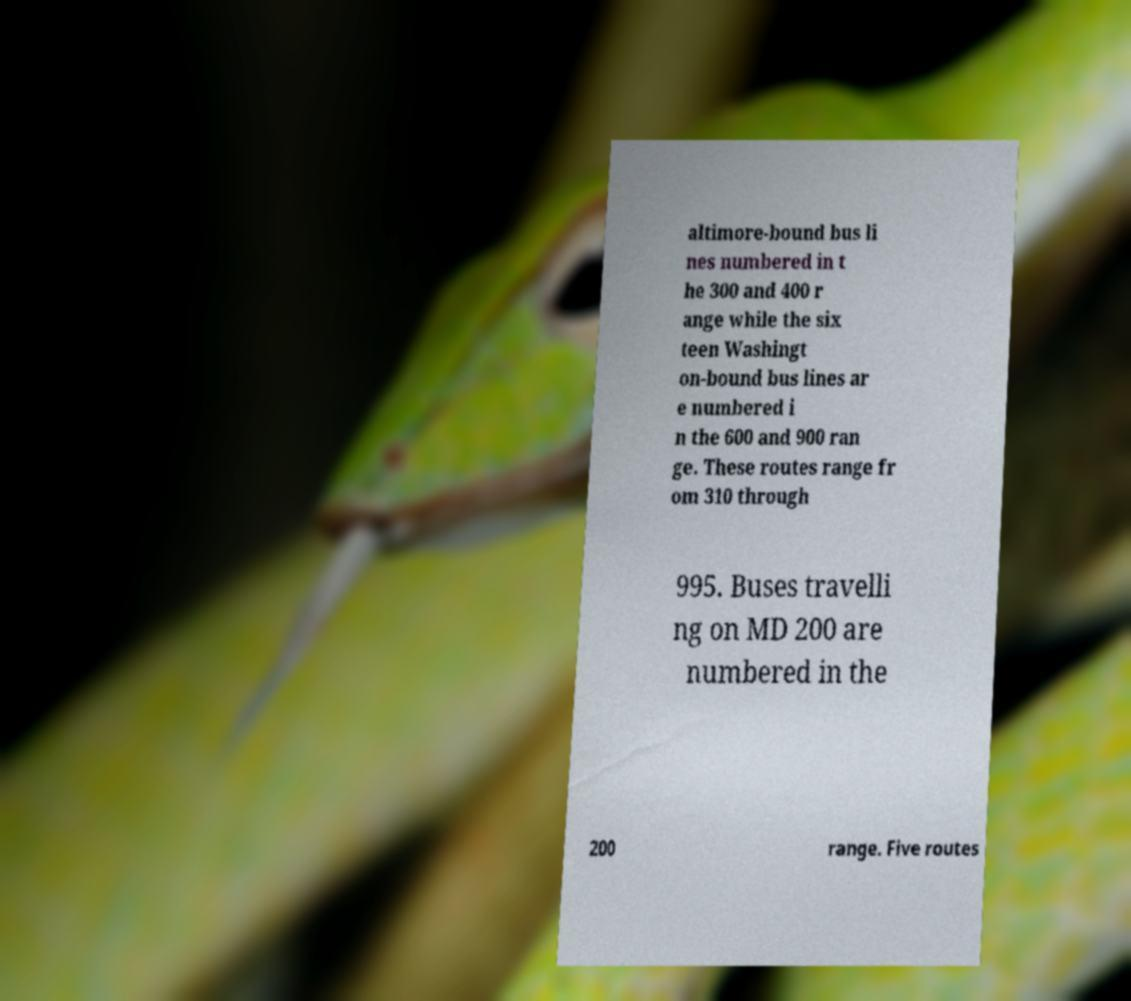There's text embedded in this image that I need extracted. Can you transcribe it verbatim? altimore-bound bus li nes numbered in t he 300 and 400 r ange while the six teen Washingt on-bound bus lines ar e numbered i n the 600 and 900 ran ge. These routes range fr om 310 through 995. Buses travelli ng on MD 200 are numbered in the 200 range. Five routes 